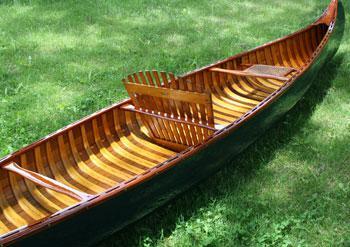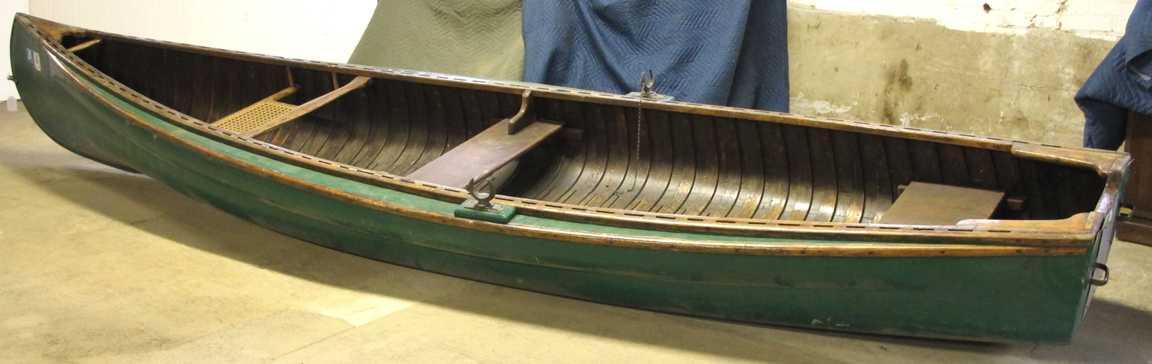The first image is the image on the left, the second image is the image on the right. For the images shown, is this caption "The right image shows a green canoe lying on grass." true? Answer yes or no. No. 